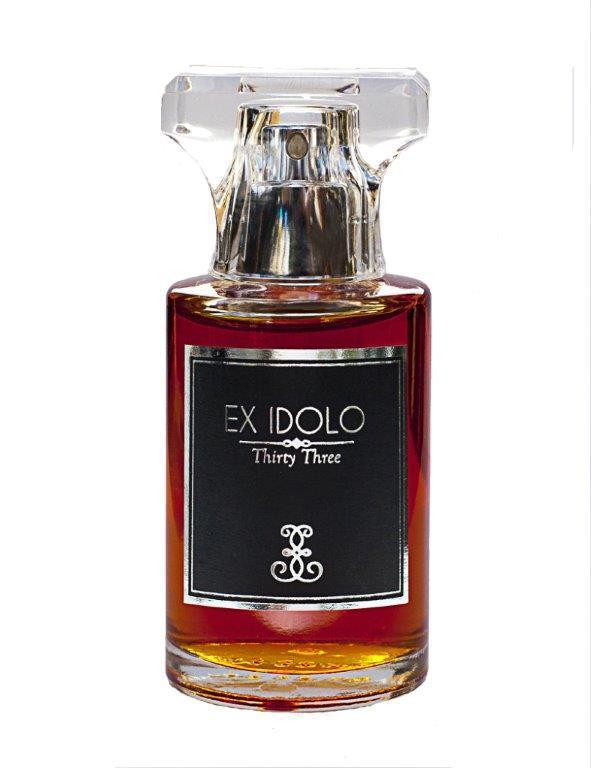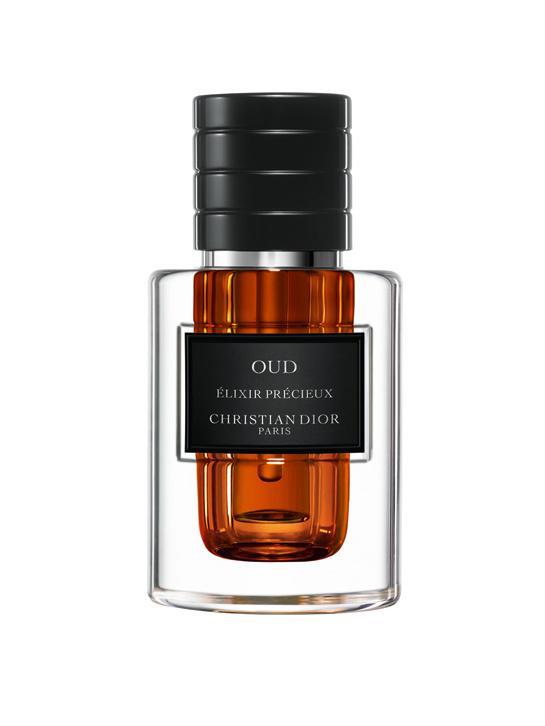The first image is the image on the left, the second image is the image on the right. Examine the images to the left and right. Is the description "There is a bottle of perfume being displayed in the center of each image." accurate? Answer yes or no. Yes. The first image is the image on the left, the second image is the image on the right. Assess this claim about the two images: "One image shows a fragrance bottle of brown liquid with a black label and a glass-look cap shaped somewhat like a T.". Correct or not? Answer yes or no. Yes. 